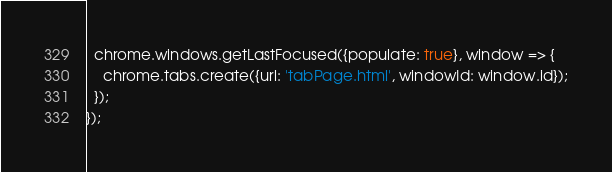<code> <loc_0><loc_0><loc_500><loc_500><_JavaScript_>  chrome.windows.getLastFocused({populate: true}, window => {
    chrome.tabs.create({url: 'tabPage.html', windowId: window.id});
  });
});
</code> 